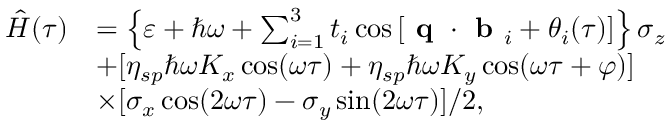<formula> <loc_0><loc_0><loc_500><loc_500>\begin{array} { r l } { \hat { H } ( \tau ) } & { = \left \{ \varepsilon + \hbar { \omega } + \sum _ { i = 1 } ^ { 3 } t _ { i } \cos \left [ q \cdot b _ { i } + \theta _ { i } ( \tau ) \right ] \right \} \sigma _ { z } } \\ & { + [ \eta _ { s p } \hbar { \omega } K _ { x } \cos ( \omega \tau ) + \eta _ { s p } \hbar { \omega } K _ { y } \cos ( \omega \tau + \varphi ) ] } \\ & { \times [ \sigma _ { x } \cos ( 2 \omega \tau ) - \sigma _ { y } \sin ( 2 \omega \tau ) ] / 2 , } \end{array}</formula> 